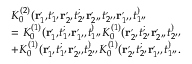Convert formula to latex. <formula><loc_0><loc_0><loc_500><loc_500>\begin{array} { r l } & { K _ { 0 } ^ { ( 2 ) } ( r _ { 1 ^ { \prime } } ^ { , } t _ { 1 ^ { \prime } } ^ { , } r _ { 2 ^ { \prime } } ^ { , } t _ { 2 ^ { \prime } } ^ { ; } r _ { 2 ^ { \prime \prime } } ^ { , } t _ { 2 ^ { \prime \prime } } ^ { , } r _ { 1 ^ { \prime \prime } } ^ { , } t _ { 1 ^ { \prime \prime } } ^ { ) } } \\ & { = K _ { 0 } ^ { ( 1 ) } ( r _ { 1 ^ { \prime } } ^ { , } t _ { 1 ^ { \prime } } ^ { ; } r _ { 1 ^ { \prime \prime } } ^ { , } t _ { 1 ^ { \prime \prime } } ^ { ) } K _ { 0 } ^ { ( 1 ) } ( r _ { 2 ^ { \prime } } ^ { , } t _ { 2 ^ { \prime } } ^ { ; } r _ { 2 ^ { \prime \prime } } ^ { , } t _ { 2 ^ { \prime \prime } } ^ { ) } } \\ & { + K _ { 0 } ^ { ( 1 ) } ( r _ { 1 ^ { \prime } } ^ { , } t _ { 1 ^ { \prime } } ^ { ; } r _ { 2 ^ { \prime \prime } } ^ { , } t _ { 2 ^ { \prime \prime } } ^ { ) } K _ { 0 } ^ { ( 1 ) } ( r _ { 2 ^ { \prime } } ^ { , } t _ { 2 ^ { \prime } } ^ { ; } r _ { 1 ^ { \prime \prime } } ^ { , } t _ { 1 ^ { \prime \prime } } ^ { ) } . } \end{array}</formula> 